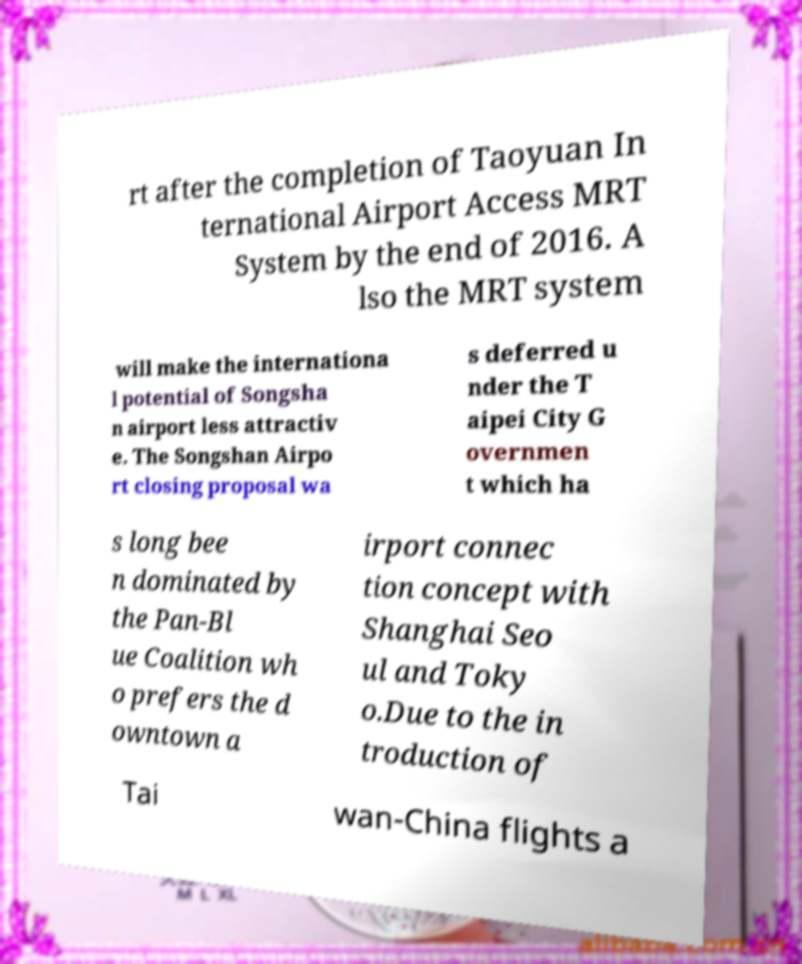There's text embedded in this image that I need extracted. Can you transcribe it verbatim? rt after the completion of Taoyuan In ternational Airport Access MRT System by the end of 2016. A lso the MRT system will make the internationa l potential of Songsha n airport less attractiv e. The Songshan Airpo rt closing proposal wa s deferred u nder the T aipei City G overnmen t which ha s long bee n dominated by the Pan-Bl ue Coalition wh o prefers the d owntown a irport connec tion concept with Shanghai Seo ul and Toky o.Due to the in troduction of Tai wan-China flights a 